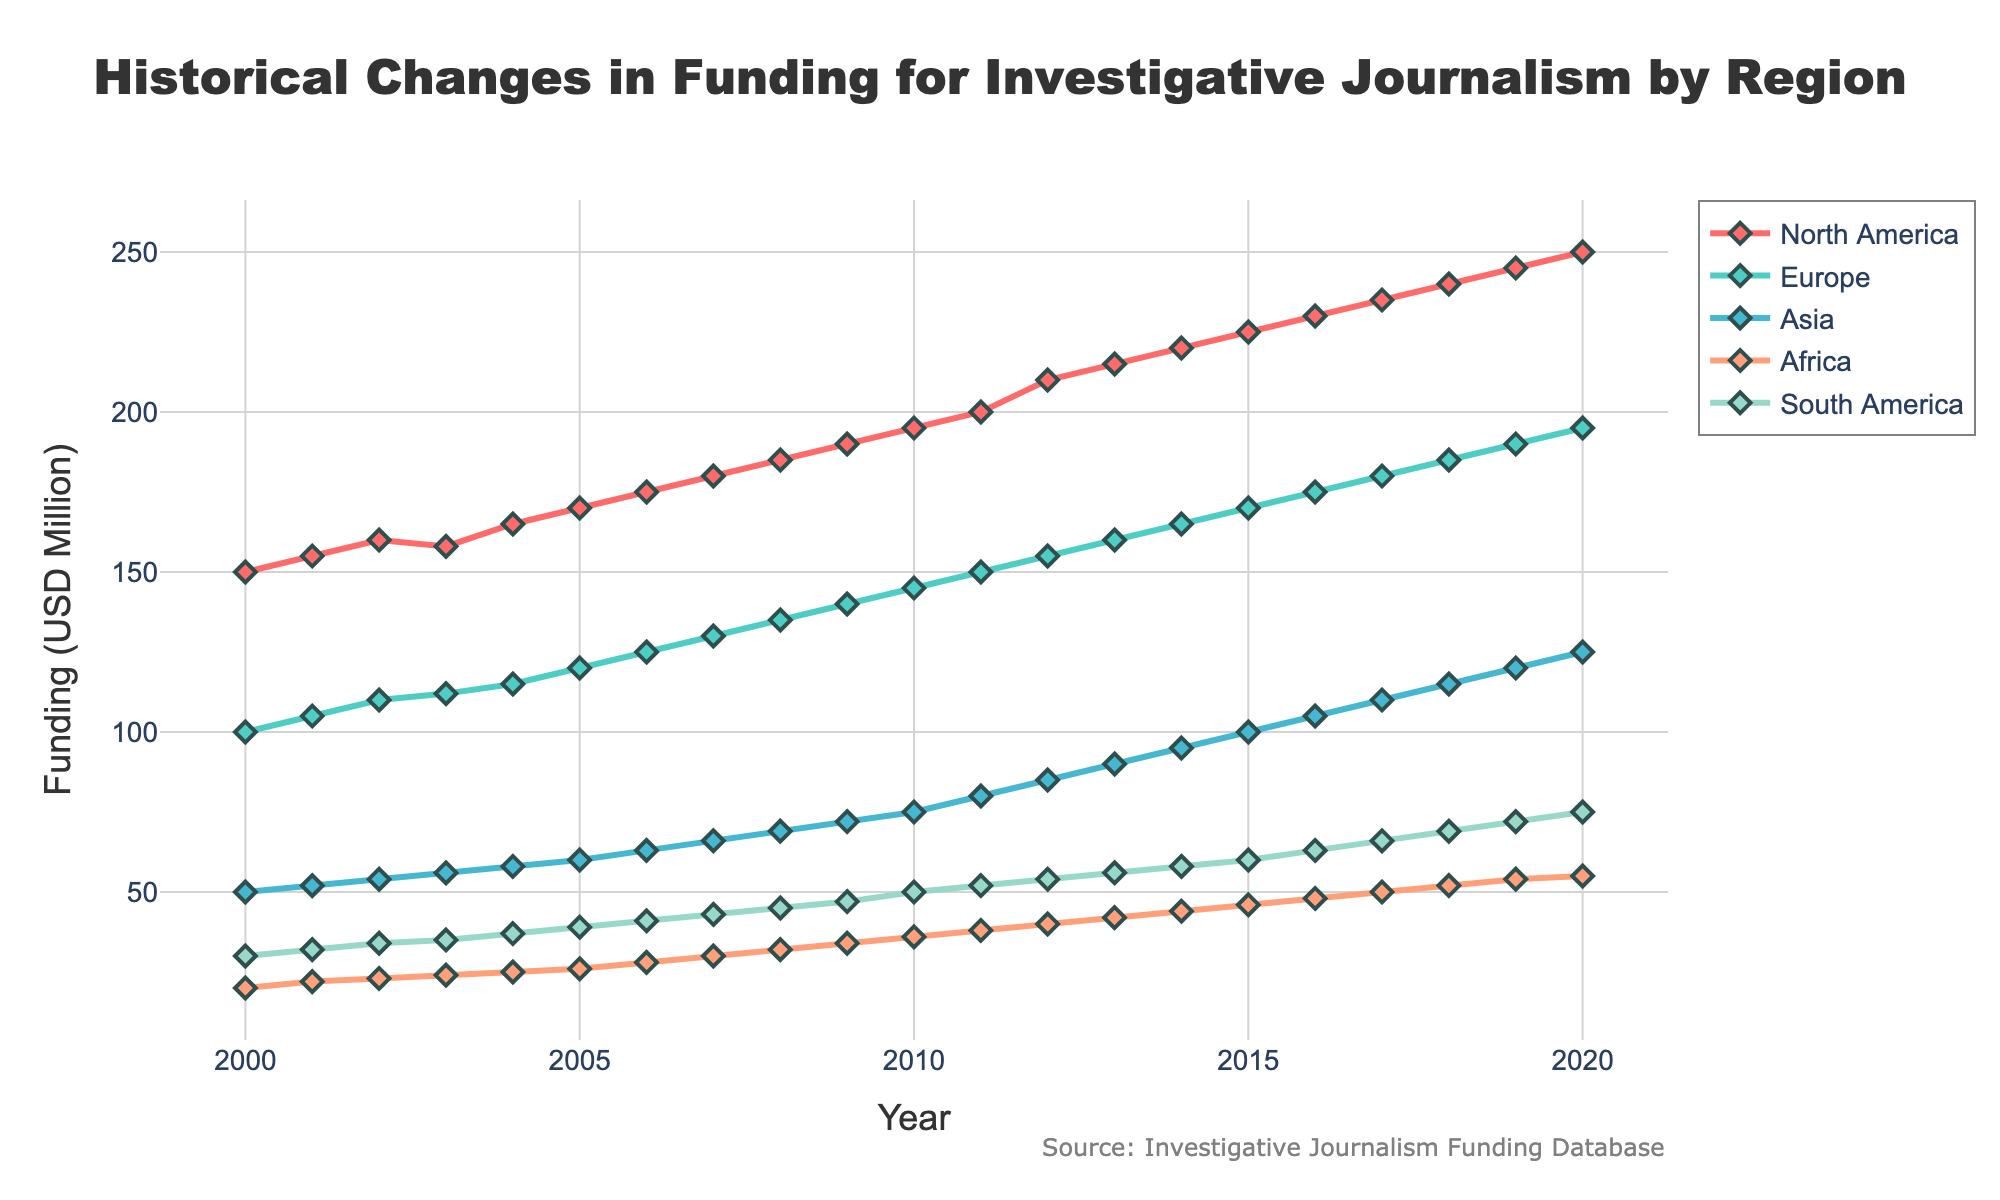What is the title of the figure? The title is found at the top of the figure. It is clearly mentioned in a large, bold font.
Answer: Historical Changes in Funding for Investigative Journalism by Region How much funding did North America receive in the year 2000? Locate the North America time series on the plot and find the corresponding funding value for the year 2000.
Answer: 150 USD Million What is the total funding received by Europe from 2000 to 2020? Sum the funding amounts for Europe from 2000 to 2020. (100 + 105 + 110 + 112 + 115 + 120 + 125 + 130 + 135 + 140 + 145 + 150 + 155 + 160 + 165 + 170 + 175 + 180 + 185 + 190 + 195)
Answer: 3017 USD Million Which region experienced the highest increase in funding between 2000 and 2020? Compare the funding differences between 2000 and 2020 for each region. North America went from 150 to 250, Europe from 100 to 195, Asia from 50 to 125, Africa from 20 to 55, South America from 30 to 75. Calculate the difference for each region.
Answer: North America Which region had the least funding overall in the year 2010? Check the funding values for all regions for the year 2010. Compare them to determine the least.
Answer: Africa What is the difference in funding between North America and Europe in 2020? Subtract the funding of Europe from the funding of North America for the year 2020. (250 - 195)
Answer: 55 USD Million Which region has shown the most consistent increase in funding over the 21 years? Evaluate the funding trends by looking at the slope and linearity of each region’s time series. Identify the region with the steady increase year over year.
Answer: Asia By how much did the funding for South America increase from 2000 to 2020? Subtract the funding value in 2000 from that in 2020 for South America. (75 - 30)
Answer: 45 USD Million Did any region experience a decrease in funding at any point in the timeline? Examine each region's funding series to check for any dips in the funding values over the years.
Answer: North America (between 2002 and 2003) 